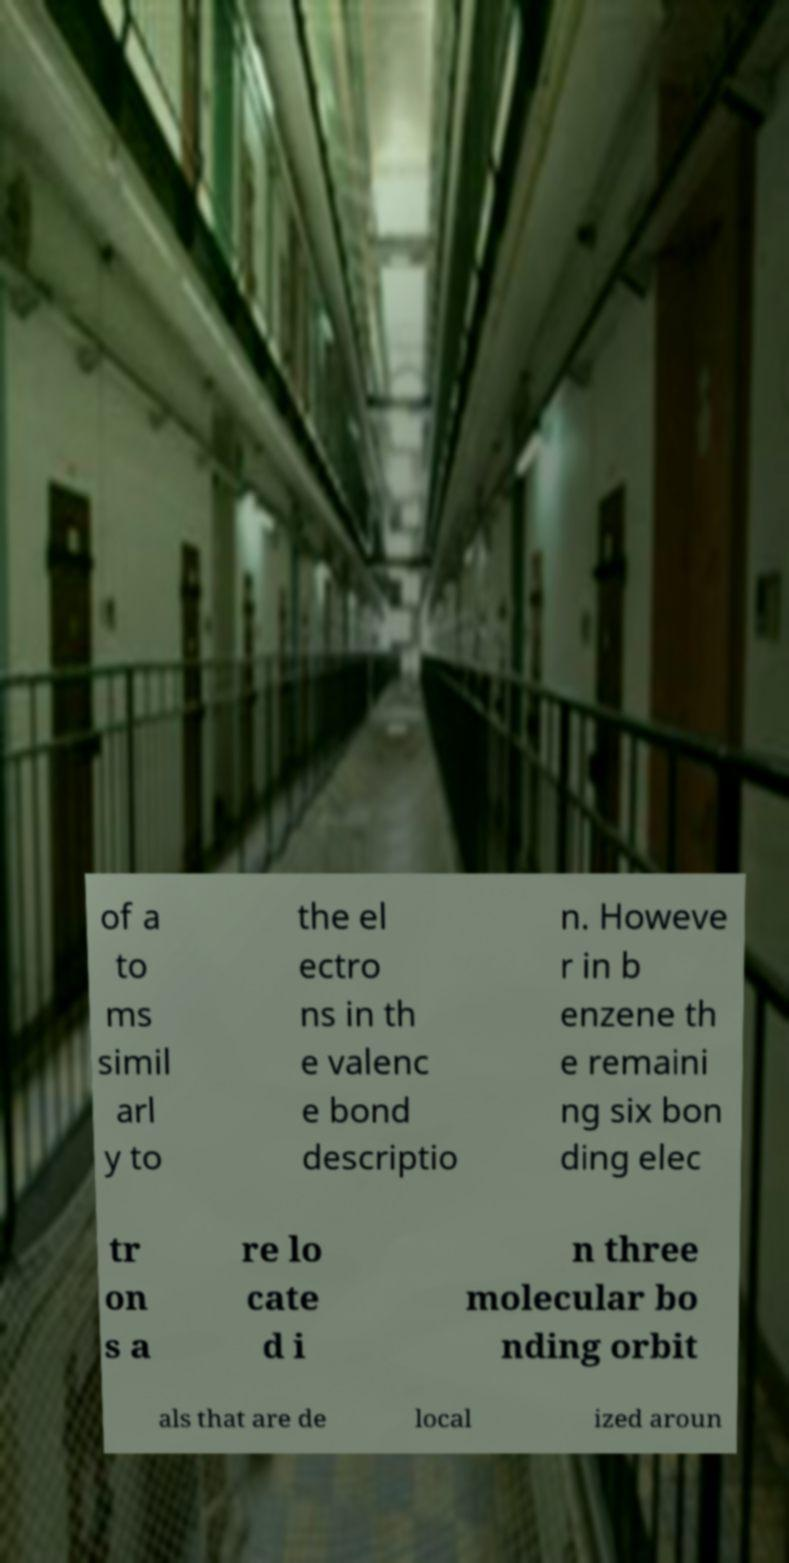Please read and relay the text visible in this image. What does it say? of a to ms simil arl y to the el ectro ns in th e valenc e bond descriptio n. Howeve r in b enzene th e remaini ng six bon ding elec tr on s a re lo cate d i n three molecular bo nding orbit als that are de local ized aroun 